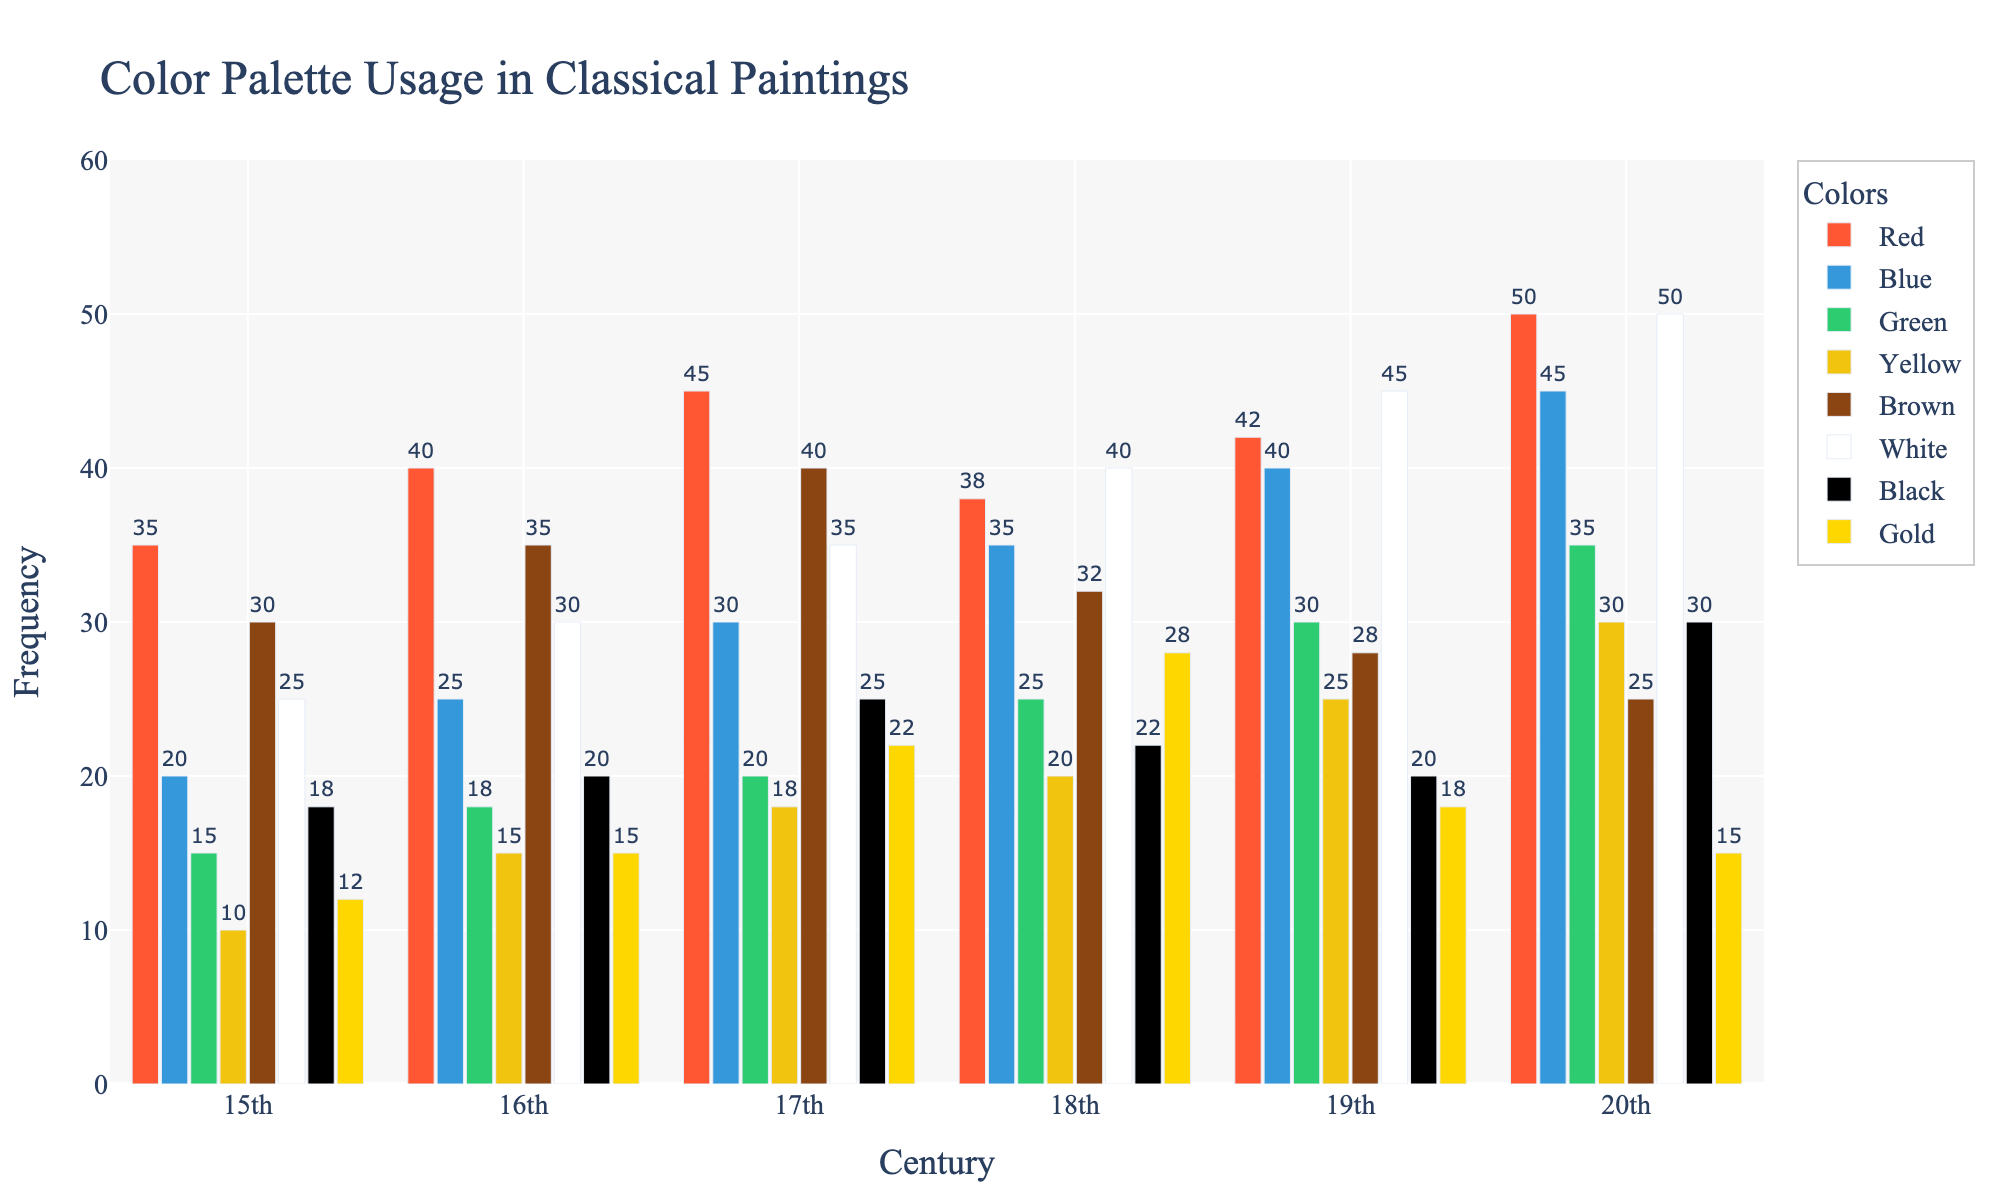Which century shows the highest frequency of the color white? In the chart, locate the white bars across all centuries and observe their heights. The highest white bar corresponds to the 20th century.
Answer: 20th century Which century used the color red the least frequently? Look for the shortest red bar among all the centuries. The 15th century has the shortest red bar.
Answer: 15th century What is the total frequency of the color blue in the 16th and 18th centuries combined? Find the heights of the blue bars for both the 16th and 18th centuries and add them together (25 + 35 = 60).
Answer: 60 Which color saw the greatest increase in usage from the 19th to the 20th century? Observe the difference in heights between each color's bar from the 19th century to the 20th century. The color white increased the most, from 45 to 50.
Answer: White Which centroid has used gold in the most balanced manner (closest to the average frequency)? First, find the average frequency of gold over all centuries ((12 + 15 + 22 + 28 + 18 + 15) / 6 = 18.33). Then, compare each century's gold usage to this average. The 19th century's usage is closest to the average (18).
Answer: 19th century What is the difference in the frequency of the color brown between the 15th century and the 17th century? Look at the height of the brown bars for the 15th and 17th centuries. Subtract the shorter bar height from the taller one (40 - 30 = 10).
Answer: 10 Which colors increased in usage every single century from the 15th to the 20th? Examine each color's bar height across all centuries sequentially. The colors red and blue show a consistent increase.
Answer: Red, Blue How much more frequently was green used in the 20th century compared to the 16th century? Find the heights of the green bars for both the 16th and 20th centuries. Subtract the frequency in the 16th century from the frequency in the 20th century (35 - 18 = 17).
Answer: 17 Which century has the least variety in color usage (smallest range between the highest and lowest frequency color)? For each century, find the difference between the highest and lowest color frequencies and identify which century has the smallest range. For the 19th century, the range is the smallest (45 - 18 = 27).
Answer: 19th century How did the usage of black change from the 15th to the 20th century? Observe the black bars for the 15th and 20th centuries and note the difference (30 - 18 = 12). The usage increased by 12.
Answer: Increased by 12 